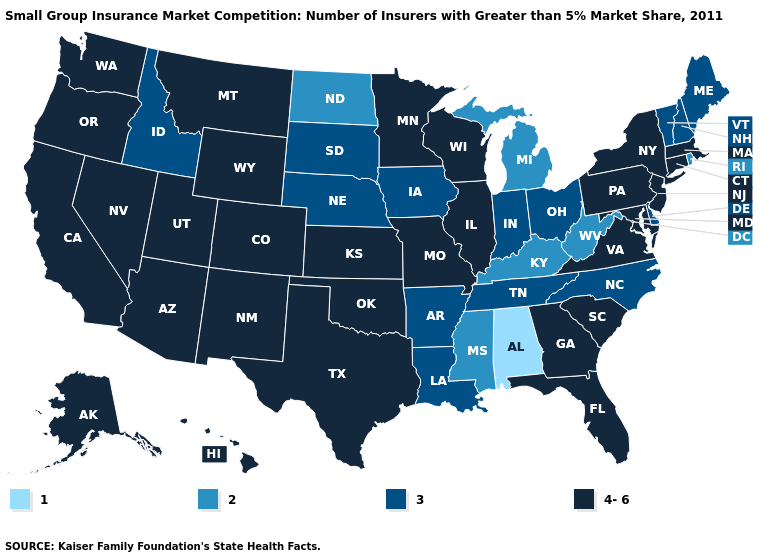Does Idaho have the highest value in the West?
Short answer required. No. Name the states that have a value in the range 1?
Give a very brief answer. Alabama. What is the value of South Dakota?
Quick response, please. 3. What is the lowest value in the MidWest?
Write a very short answer. 2. Name the states that have a value in the range 4-6?
Concise answer only. Alaska, Arizona, California, Colorado, Connecticut, Florida, Georgia, Hawaii, Illinois, Kansas, Maryland, Massachusetts, Minnesota, Missouri, Montana, Nevada, New Jersey, New Mexico, New York, Oklahoma, Oregon, Pennsylvania, South Carolina, Texas, Utah, Virginia, Washington, Wisconsin, Wyoming. Does the map have missing data?
Be succinct. No. Name the states that have a value in the range 1?
Give a very brief answer. Alabama. What is the value of Iowa?
Quick response, please. 3. Among the states that border South Carolina , does North Carolina have the lowest value?
Concise answer only. Yes. What is the value of Illinois?
Answer briefly. 4-6. Does New York have a higher value than Missouri?
Keep it brief. No. Name the states that have a value in the range 1?
Quick response, please. Alabama. Does Alabama have the lowest value in the USA?
Short answer required. Yes. Does the first symbol in the legend represent the smallest category?
Concise answer only. Yes. Which states hav the highest value in the Northeast?
Quick response, please. Connecticut, Massachusetts, New Jersey, New York, Pennsylvania. 